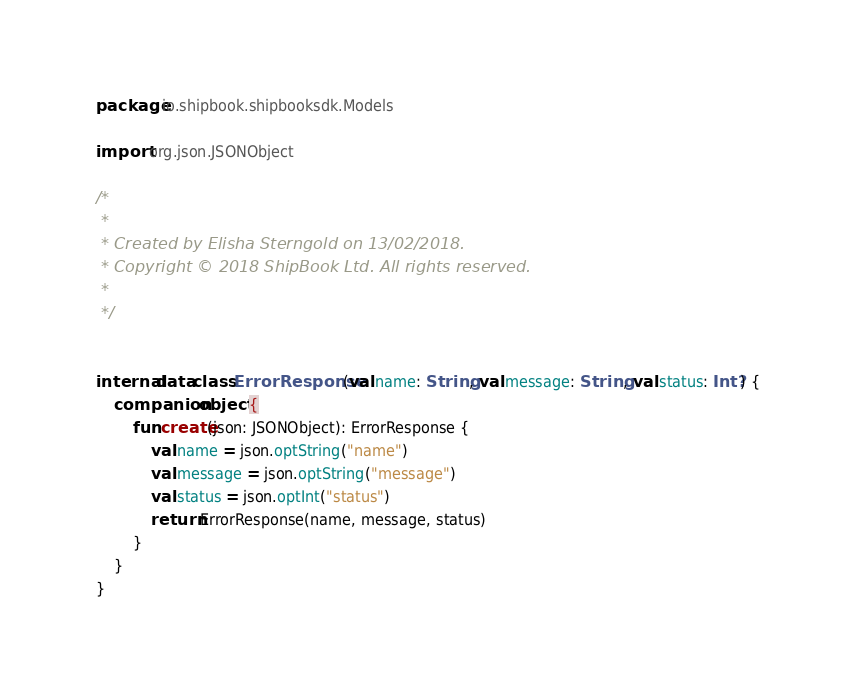Convert code to text. <code><loc_0><loc_0><loc_500><loc_500><_Kotlin_>package io.shipbook.shipbooksdk.Models

import org.json.JSONObject

/*
 *
 * Created by Elisha Sterngold on 13/02/2018.
 * Copyright © 2018 ShipBook Ltd. All rights reserved.
 *
 */


internal data class ErrorResponse (val name: String, val message: String, val status: Int?) {
    companion object {
        fun create(json: JSONObject): ErrorResponse {
            val name = json.optString("name")
            val message = json.optString("message")
            val status = json.optInt("status")
            return ErrorResponse(name, message, status)
        }
    }
}</code> 